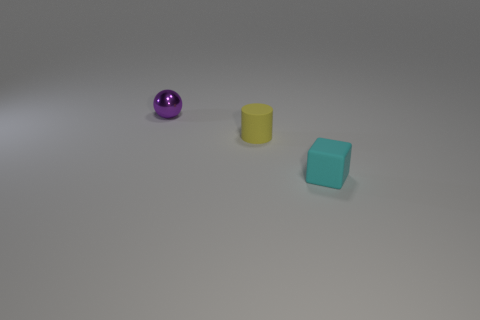Is there any other thing that is the same material as the cylinder?
Offer a terse response. Yes. There is a matte thing left of the small thing in front of the tiny yellow rubber cylinder; what number of cyan matte blocks are in front of it?
Ensure brevity in your answer.  1. What number of other shiny objects are the same shape as the tiny yellow thing?
Give a very brief answer. 0. There is a small matte thing that is behind the small cyan matte cube; is its color the same as the shiny sphere?
Your answer should be compact. No. The matte object behind the small object that is in front of the small matte object that is behind the cyan block is what shape?
Your answer should be very brief. Cylinder. There is a yellow cylinder; is its size the same as the thing behind the rubber cylinder?
Your answer should be compact. Yes. Are there any metallic blocks of the same size as the cylinder?
Provide a succinct answer. No. What number of other things are there of the same material as the small yellow thing
Provide a succinct answer. 1. There is a tiny object that is both on the right side of the small purple sphere and behind the block; what is its color?
Your answer should be compact. Yellow. Does the object to the right of the yellow matte cylinder have the same material as the tiny object that is left of the small yellow cylinder?
Provide a succinct answer. No. 